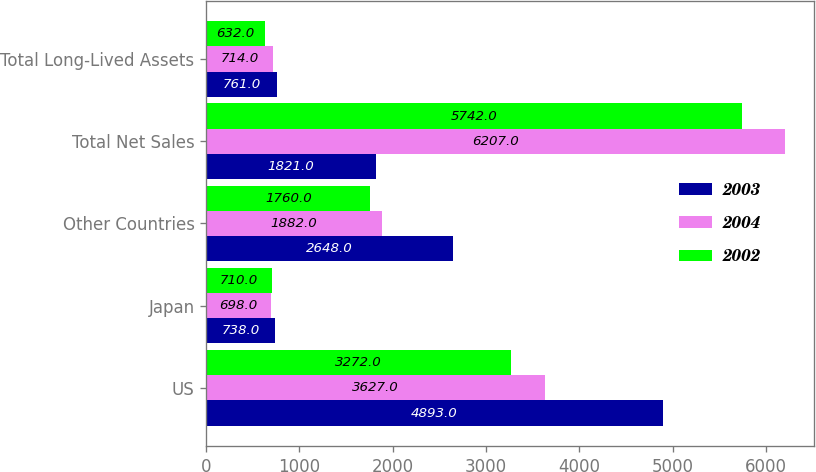Convert chart. <chart><loc_0><loc_0><loc_500><loc_500><stacked_bar_chart><ecel><fcel>US<fcel>Japan<fcel>Other Countries<fcel>Total Net Sales<fcel>Total Long-Lived Assets<nl><fcel>2003<fcel>4893<fcel>738<fcel>2648<fcel>1821<fcel>761<nl><fcel>2004<fcel>3627<fcel>698<fcel>1882<fcel>6207<fcel>714<nl><fcel>2002<fcel>3272<fcel>710<fcel>1760<fcel>5742<fcel>632<nl></chart> 